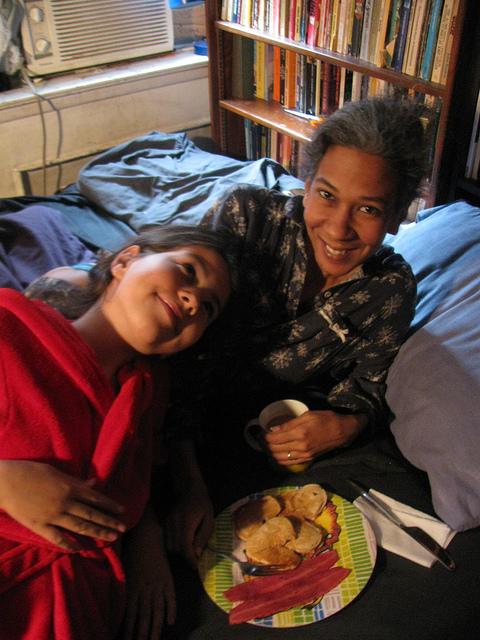What are they eating?
Give a very brief answer. Breakfast. How many people are in the image?
Concise answer only. 2. What is on the shelf?
Concise answer only. Books. 